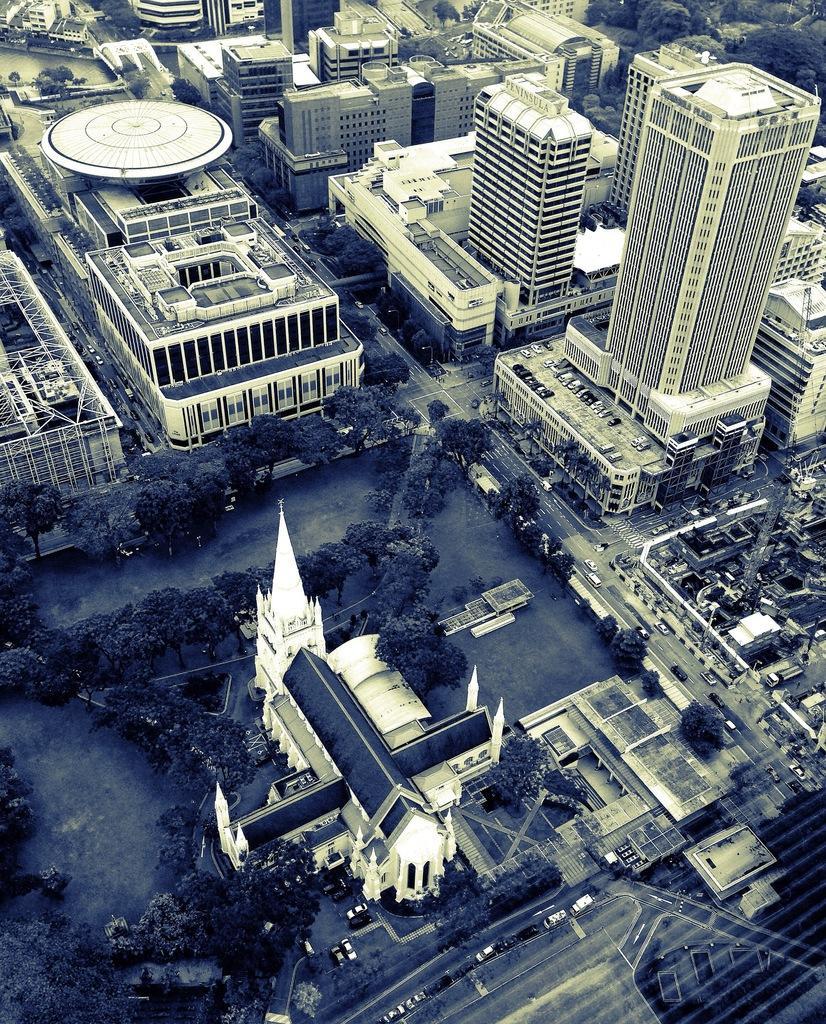Can you describe this image briefly? In this image we can see buildings, skyscrapers, motor vehicles on the road, motor vehicles in the parking slots, trees, grounds and poles. 